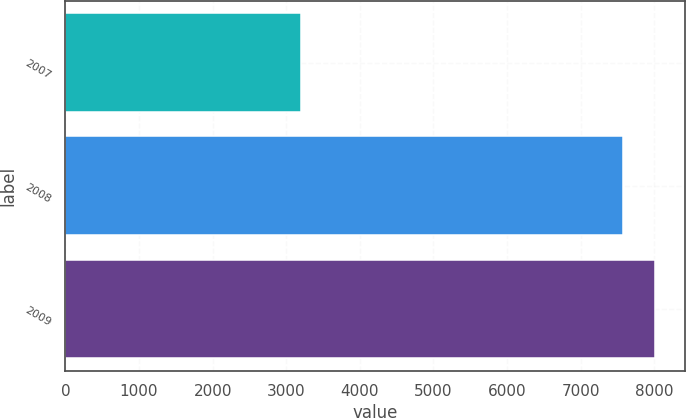<chart> <loc_0><loc_0><loc_500><loc_500><bar_chart><fcel>2007<fcel>2008<fcel>2009<nl><fcel>3206<fcel>7577<fcel>8014.1<nl></chart> 